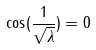Convert formula to latex. <formula><loc_0><loc_0><loc_500><loc_500>\cos ( \frac { 1 } { \sqrt { \lambda } } ) = 0</formula> 